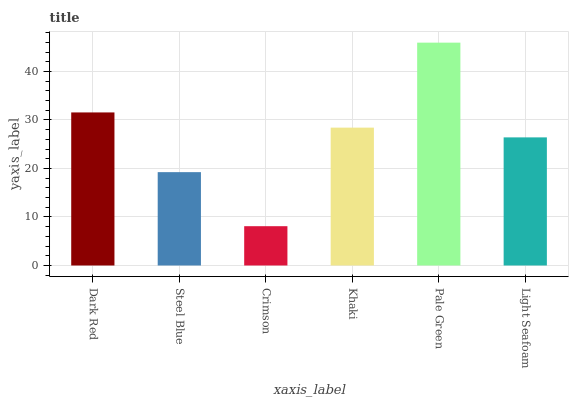Is Steel Blue the minimum?
Answer yes or no. No. Is Steel Blue the maximum?
Answer yes or no. No. Is Dark Red greater than Steel Blue?
Answer yes or no. Yes. Is Steel Blue less than Dark Red?
Answer yes or no. Yes. Is Steel Blue greater than Dark Red?
Answer yes or no. No. Is Dark Red less than Steel Blue?
Answer yes or no. No. Is Khaki the high median?
Answer yes or no. Yes. Is Light Seafoam the low median?
Answer yes or no. Yes. Is Crimson the high median?
Answer yes or no. No. Is Steel Blue the low median?
Answer yes or no. No. 